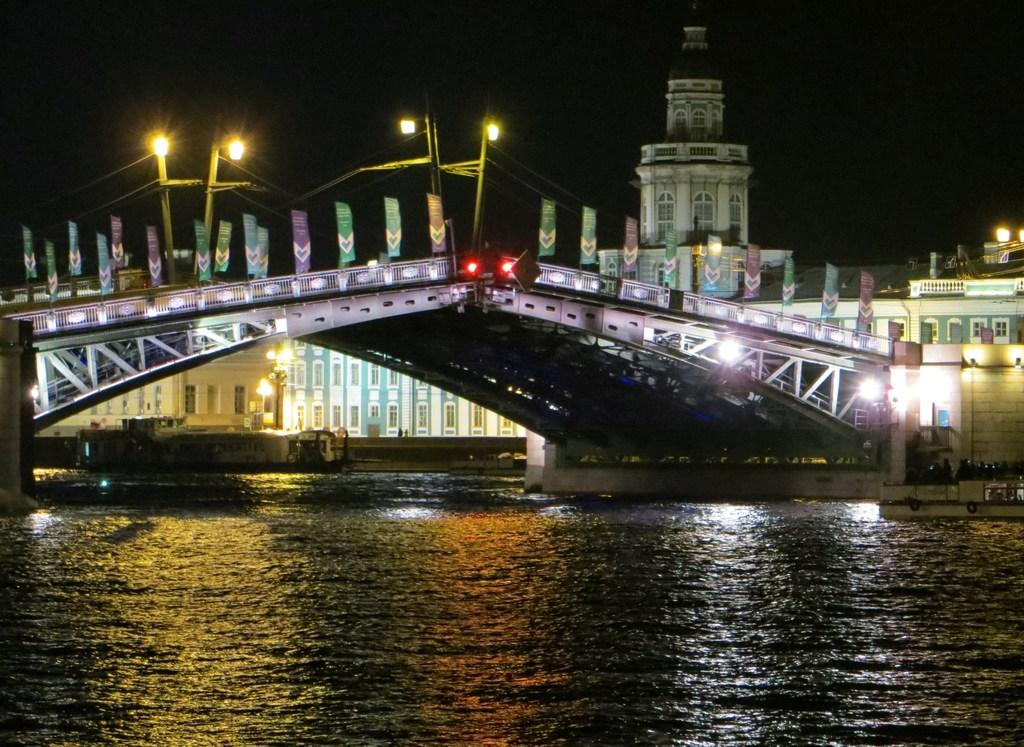What is at the bottom of the image? There is a surface of water at the bottom of the image. What can be seen in the middle of the image? There is a bridge and a building in the middle of the image. What is visible at the top of the image? There are lights at the top of the image. What type of pest can be seen causing problems on the bridge in the image? There are no pests visible in the image, and the bridge appears to be in good condition. What emotion is being expressed by the building in the image? Buildings do not express emotions; they are inanimate objects. 